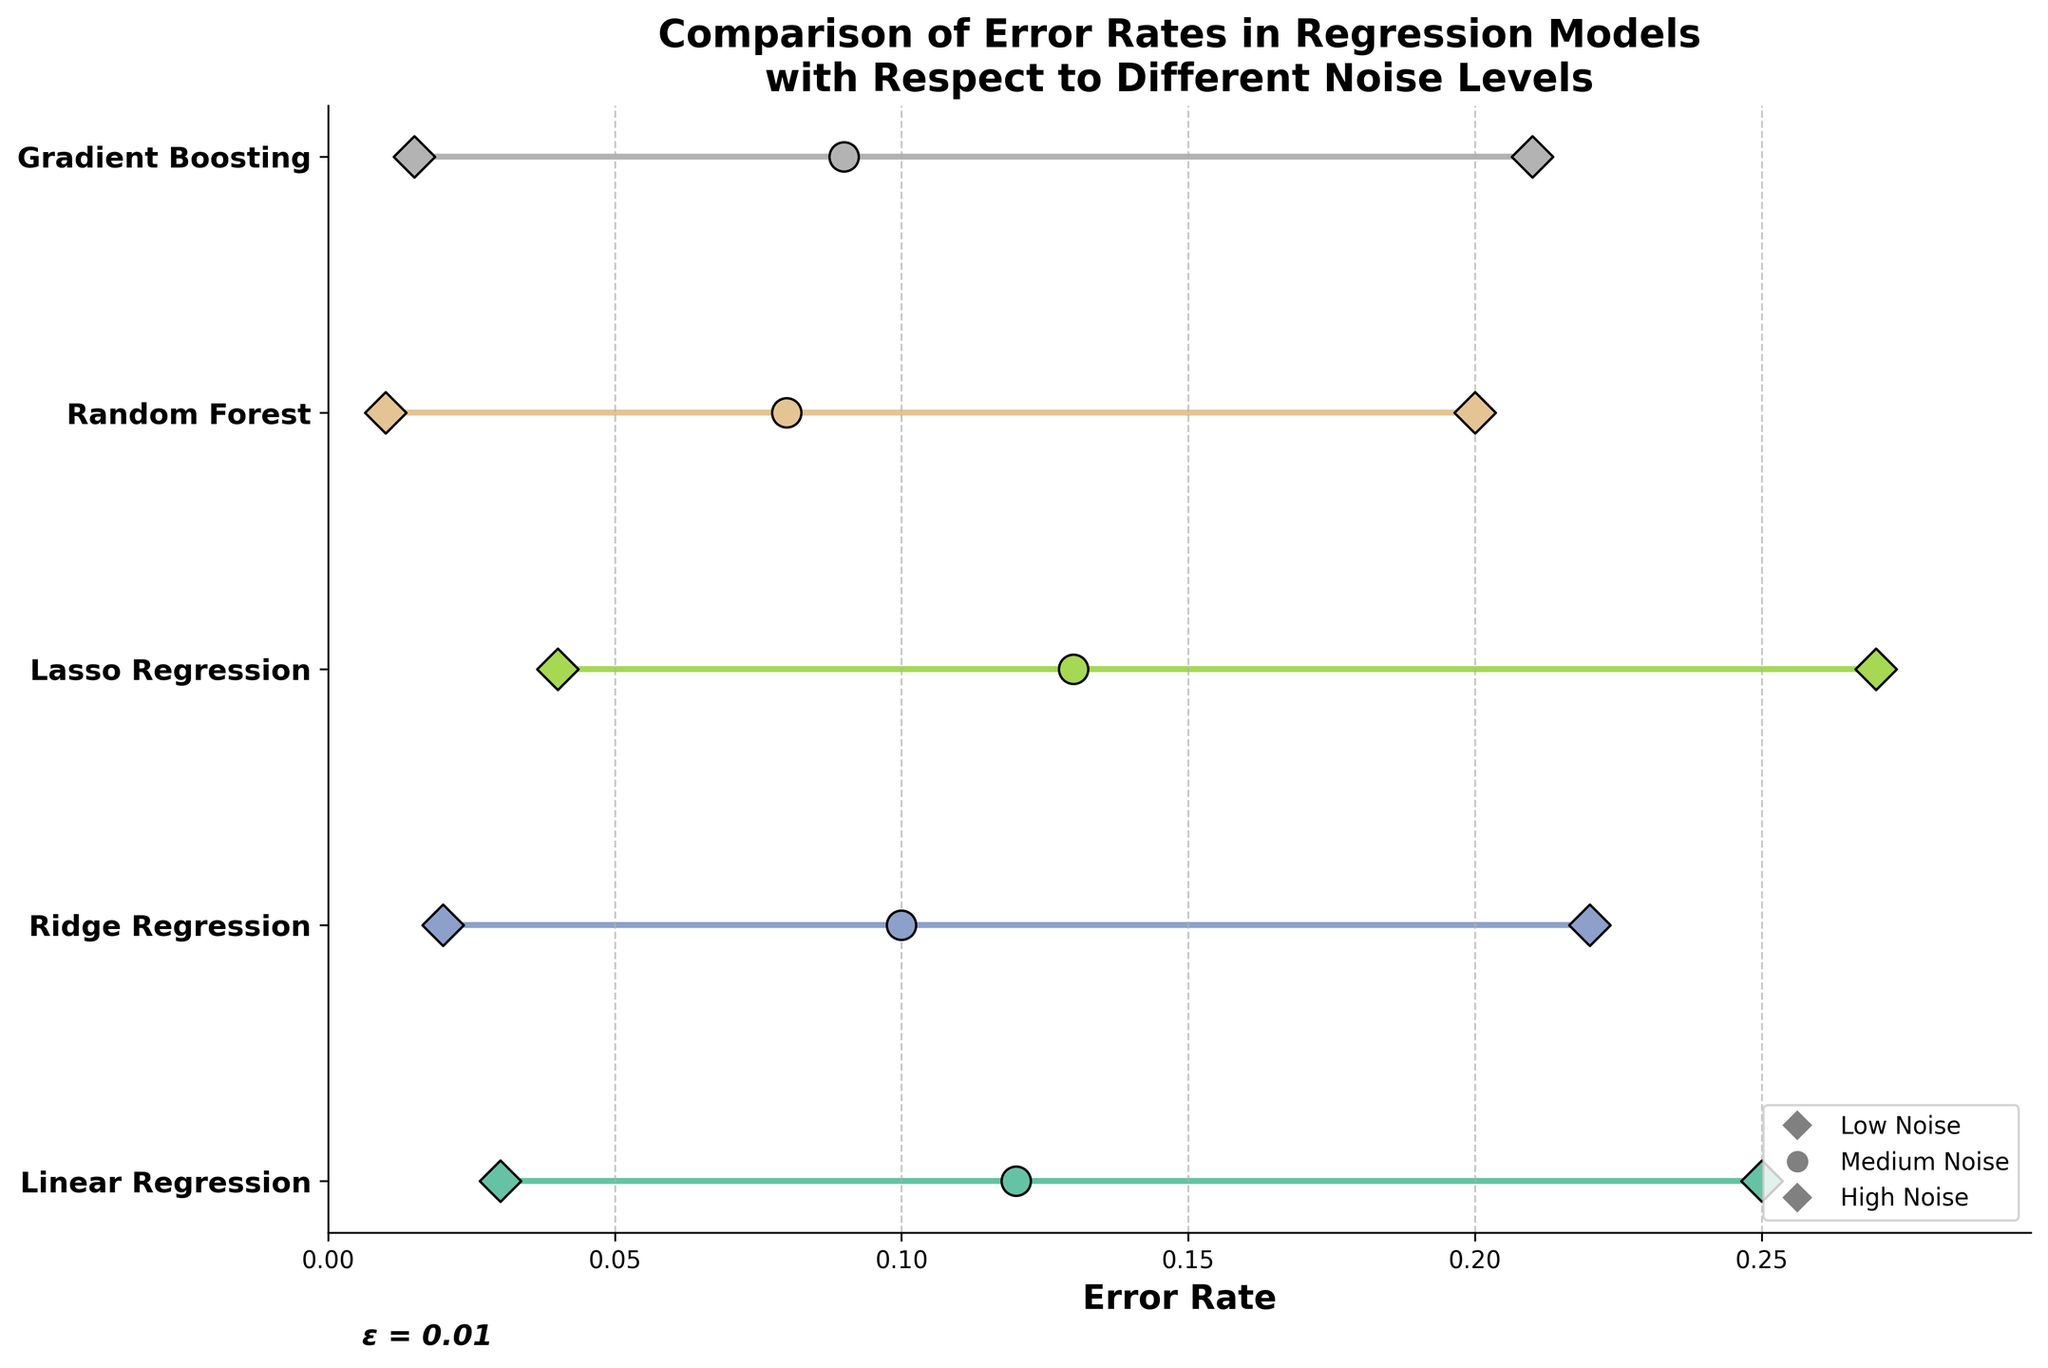what is the title of the plot? The title is located at the top of the plot and is directly readable. It provides the context of the visual information displayed.
Answer: Comparison of Error Rates in Regression Models with Respect to Different Noise Levels What models have the lowest error rate at high noise levels? To determine which models have the lowest error rate at high noise levels, we look at the points corresponding to 'High' noise levels on the right side of the y-axis labels and identify which point has the lowest value.
Answer: Random Forest and Gradient Boosting What is the error rate difference for Linear Regression between high and low noise levels? First, identify the error rates for Linear Regression at high and low noise levels, then subtract the low noise level error rate from the high noise level error rate. For Linear Regression: high is 0.25 and low is 0.03. The difference is 0.25 - 0.03.
Answer: 0.22 Which models show a decrease in error rate from medium to high noise levels? Find the models where the error rate at 'Medium' noise levels is higher than at 'High' noise levels. Compare the 'Medium' and 'High' points for each model. Check for any instances where the 'Medium' point is above the 'High' point.
Answer: None What is the average error rate for Ridge Regression across all noise levels? Find the error rates for Ridge Regression at all noise levels and calculate their average: (0.02 + 0.10 + 0.22)/3. The sum is 0.34, and dividing by 3 gives the average.
Answer: 0.113 What does the ε = 0.01 text represent in the plot? The text "ε = 0.01" at the bottom of the plot indicates the value of epsilon, likely representing a small parameter used for adjustments or tolerances within the context of error rates, emphasizing precision.
Answer: Epsilon is 0.01 Which model has the highest error rate at low noise levels? Observe the points corresponding to the 'Low' noise levels on the left side next to each model, and find the highest value among them.
Answer: Lasso Regression What is the total range of error rates for Gradient Boosting across all noise levels? Find the minimum and maximum error rates for Gradient Boosting and calculate the range by subtracting the minimum from the maximum. Maximum is 0.21 (High), and minimum is 0.015 (Low). The range is 0.21 - 0.015.
Answer: 0.195 Which model experiences the largest increase in error rate from low to high noise levels? For each model, calculate the difference in error rates between 'High' and 'Low' noise levels and compare these differences to find the largest one. Lasso Regression: 0.27 - 0.04 = 0.23, which is the highest.
Answer: Lasso Regression 